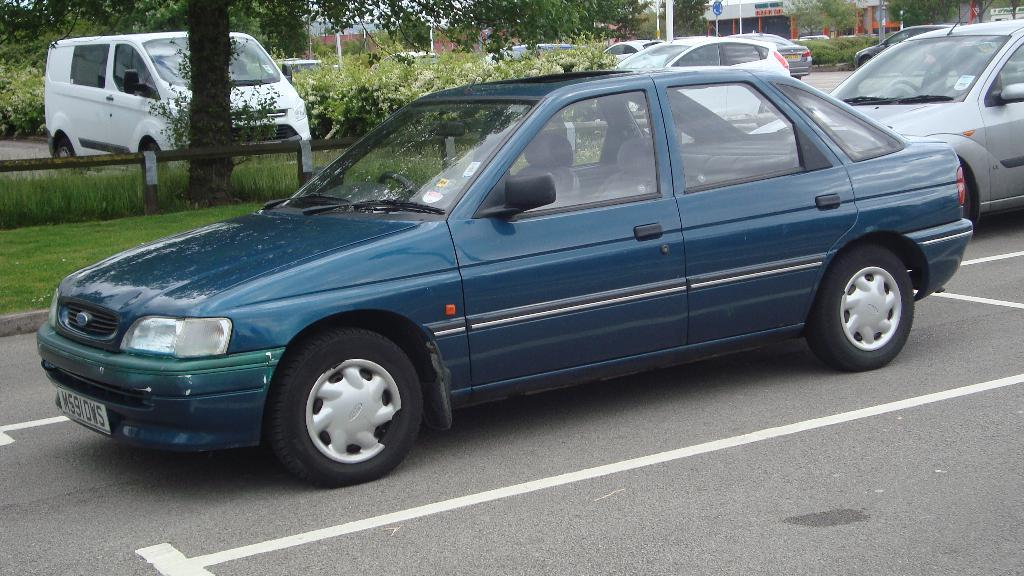What can be seen on the road in the image? There are vehicles on the road in the image. What type of natural scenery is visible in the background of the image? There are trees visible in the background of the image. What is the chance of seeing horses running on the road in the image? There are no horses visible in the image, so it is not possible to determine the chance of seeing them running on the road. 